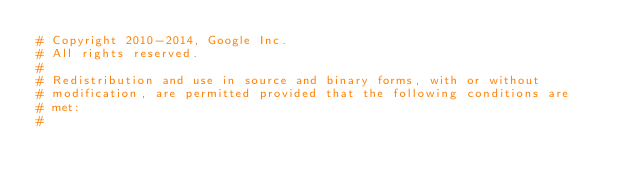<code> <loc_0><loc_0><loc_500><loc_500><_Python_># Copyright 2010-2014, Google Inc.
# All rights reserved.
#
# Redistribution and use in source and binary forms, with or without
# modification, are permitted provided that the following conditions are
# met:
#</code> 